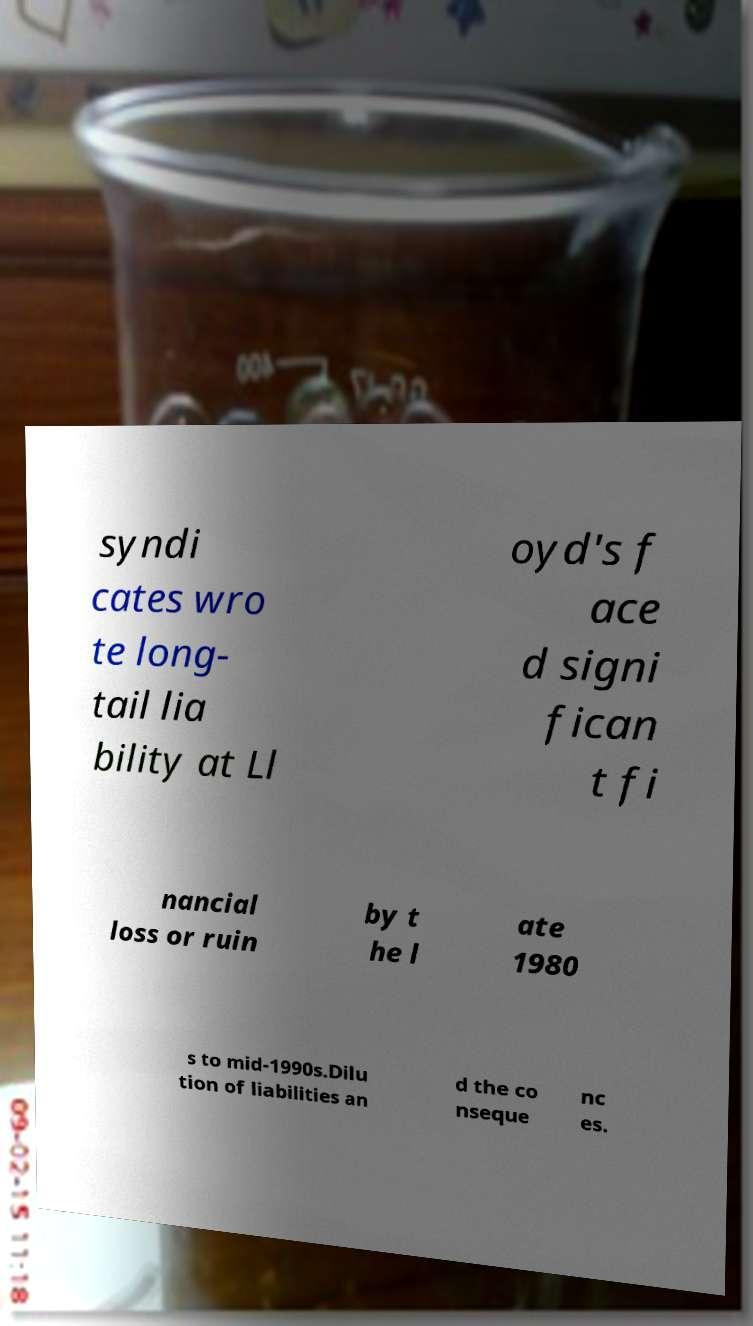What messages or text are displayed in this image? I need them in a readable, typed format. syndi cates wro te long- tail lia bility at Ll oyd's f ace d signi fican t fi nancial loss or ruin by t he l ate 1980 s to mid-1990s.Dilu tion of liabilities an d the co nseque nc es. 